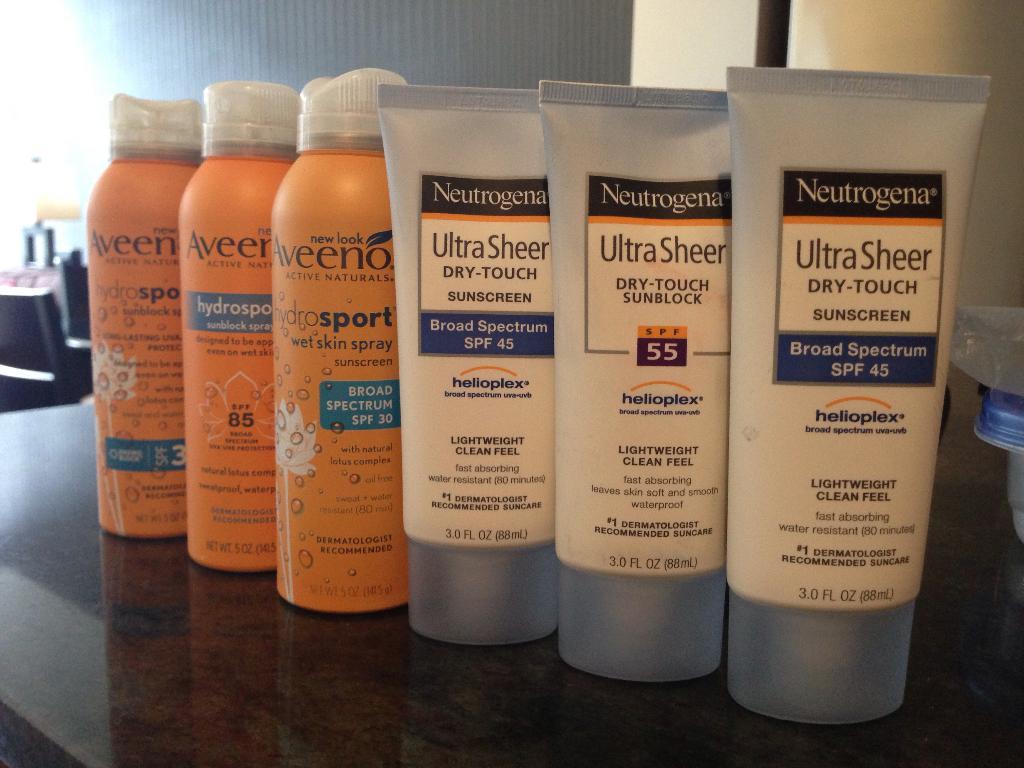What spf is the front tube?
Your response must be concise. 45. 